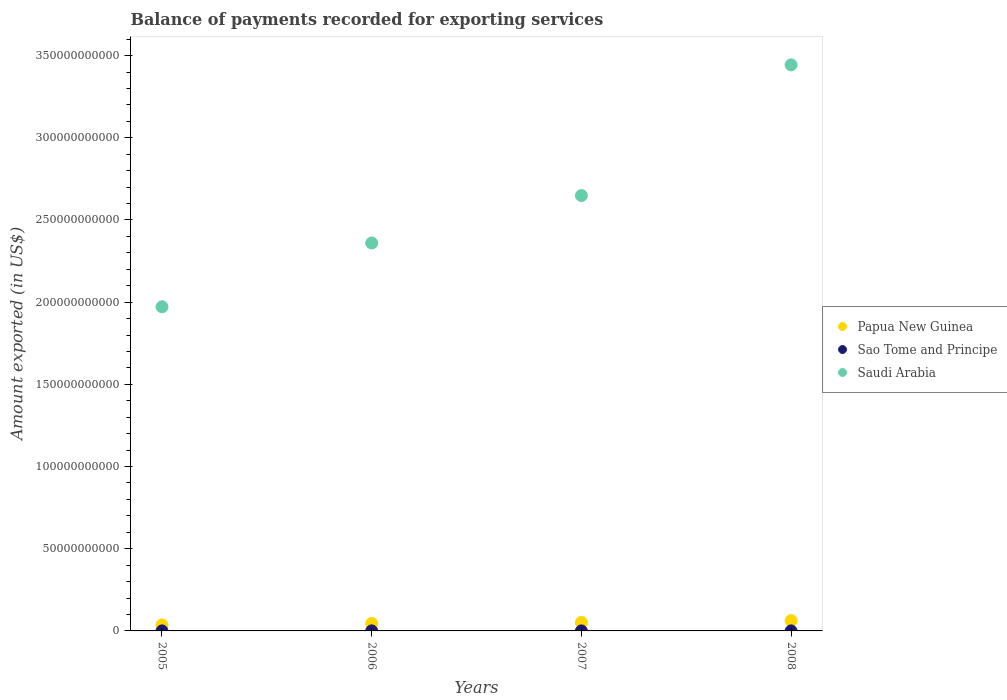How many different coloured dotlines are there?
Ensure brevity in your answer.  3. Is the number of dotlines equal to the number of legend labels?
Offer a terse response. Yes. What is the amount exported in Saudi Arabia in 2007?
Your response must be concise. 2.65e+11. Across all years, what is the maximum amount exported in Saudi Arabia?
Your answer should be compact. 3.44e+11. Across all years, what is the minimum amount exported in Sao Tome and Principe?
Give a very brief answer. 1.79e+07. In which year was the amount exported in Saudi Arabia minimum?
Your response must be concise. 2005. What is the total amount exported in Sao Tome and Principe in the graph?
Ensure brevity in your answer.  7.99e+07. What is the difference between the amount exported in Papua New Guinea in 2006 and that in 2007?
Your answer should be very brief. -6.08e+08. What is the difference between the amount exported in Saudi Arabia in 2006 and the amount exported in Sao Tome and Principe in 2008?
Provide a succinct answer. 2.36e+11. What is the average amount exported in Papua New Guinea per year?
Keep it short and to the point. 4.93e+09. In the year 2008, what is the difference between the amount exported in Saudi Arabia and amount exported in Sao Tome and Principe?
Offer a very short reply. 3.44e+11. In how many years, is the amount exported in Sao Tome and Principe greater than 30000000000 US$?
Your answer should be very brief. 0. What is the ratio of the amount exported in Papua New Guinea in 2005 to that in 2008?
Your answer should be compact. 0.58. What is the difference between the highest and the second highest amount exported in Papua New Guinea?
Your response must be concise. 1.05e+09. What is the difference between the highest and the lowest amount exported in Sao Tome and Principe?
Offer a very short reply. 4.35e+06. In how many years, is the amount exported in Sao Tome and Principe greater than the average amount exported in Sao Tome and Principe taken over all years?
Your answer should be compact. 2. Is the sum of the amount exported in Saudi Arabia in 2007 and 2008 greater than the maximum amount exported in Sao Tome and Principe across all years?
Offer a terse response. Yes. Is it the case that in every year, the sum of the amount exported in Saudi Arabia and amount exported in Sao Tome and Principe  is greater than the amount exported in Papua New Guinea?
Ensure brevity in your answer.  Yes. Does the amount exported in Saudi Arabia monotonically increase over the years?
Provide a succinct answer. Yes. Is the amount exported in Sao Tome and Principe strictly greater than the amount exported in Papua New Guinea over the years?
Your answer should be very brief. No. How many dotlines are there?
Provide a succinct answer. 3. How many years are there in the graph?
Keep it short and to the point. 4. Are the values on the major ticks of Y-axis written in scientific E-notation?
Your answer should be very brief. No. Does the graph contain any zero values?
Your answer should be compact. No. Does the graph contain grids?
Provide a short and direct response. No. How many legend labels are there?
Offer a very short reply. 3. How are the legend labels stacked?
Your answer should be very brief. Vertical. What is the title of the graph?
Give a very brief answer. Balance of payments recorded for exporting services. Does "Liberia" appear as one of the legend labels in the graph?
Offer a terse response. No. What is the label or title of the X-axis?
Provide a short and direct response. Years. What is the label or title of the Y-axis?
Keep it short and to the point. Amount exported (in US$). What is the Amount exported (in US$) in Papua New Guinea in 2005?
Keep it short and to the point. 3.65e+09. What is the Amount exported (in US$) in Sao Tome and Principe in 2005?
Ensure brevity in your answer.  1.79e+07. What is the Amount exported (in US$) of Saudi Arabia in 2005?
Make the answer very short. 1.97e+11. What is the Amount exported (in US$) of Papua New Guinea in 2006?
Give a very brief answer. 4.60e+09. What is the Amount exported (in US$) of Sao Tome and Principe in 2006?
Ensure brevity in your answer.  2.23e+07. What is the Amount exported (in US$) in Saudi Arabia in 2006?
Your answer should be very brief. 2.36e+11. What is the Amount exported (in US$) in Papua New Guinea in 2007?
Make the answer very short. 5.20e+09. What is the Amount exported (in US$) in Sao Tome and Principe in 2007?
Keep it short and to the point. 2.03e+07. What is the Amount exported (in US$) of Saudi Arabia in 2007?
Give a very brief answer. 2.65e+11. What is the Amount exported (in US$) of Papua New Guinea in 2008?
Offer a terse response. 6.26e+09. What is the Amount exported (in US$) in Sao Tome and Principe in 2008?
Your response must be concise. 1.94e+07. What is the Amount exported (in US$) in Saudi Arabia in 2008?
Your answer should be compact. 3.44e+11. Across all years, what is the maximum Amount exported (in US$) in Papua New Guinea?
Keep it short and to the point. 6.26e+09. Across all years, what is the maximum Amount exported (in US$) of Sao Tome and Principe?
Provide a succinct answer. 2.23e+07. Across all years, what is the maximum Amount exported (in US$) in Saudi Arabia?
Provide a succinct answer. 3.44e+11. Across all years, what is the minimum Amount exported (in US$) of Papua New Guinea?
Provide a short and direct response. 3.65e+09. Across all years, what is the minimum Amount exported (in US$) of Sao Tome and Principe?
Give a very brief answer. 1.79e+07. Across all years, what is the minimum Amount exported (in US$) in Saudi Arabia?
Make the answer very short. 1.97e+11. What is the total Amount exported (in US$) of Papua New Guinea in the graph?
Provide a succinct answer. 1.97e+1. What is the total Amount exported (in US$) of Sao Tome and Principe in the graph?
Keep it short and to the point. 7.99e+07. What is the total Amount exported (in US$) of Saudi Arabia in the graph?
Make the answer very short. 1.04e+12. What is the difference between the Amount exported (in US$) of Papua New Guinea in 2005 and that in 2006?
Your response must be concise. -9.48e+08. What is the difference between the Amount exported (in US$) of Sao Tome and Principe in 2005 and that in 2006?
Give a very brief answer. -4.35e+06. What is the difference between the Amount exported (in US$) of Saudi Arabia in 2005 and that in 2006?
Ensure brevity in your answer.  -3.88e+1. What is the difference between the Amount exported (in US$) of Papua New Guinea in 2005 and that in 2007?
Make the answer very short. -1.56e+09. What is the difference between the Amount exported (in US$) of Sao Tome and Principe in 2005 and that in 2007?
Ensure brevity in your answer.  -2.36e+06. What is the difference between the Amount exported (in US$) of Saudi Arabia in 2005 and that in 2007?
Offer a very short reply. -6.77e+1. What is the difference between the Amount exported (in US$) in Papua New Guinea in 2005 and that in 2008?
Your answer should be compact. -2.61e+09. What is the difference between the Amount exported (in US$) of Sao Tome and Principe in 2005 and that in 2008?
Give a very brief answer. -1.53e+06. What is the difference between the Amount exported (in US$) in Saudi Arabia in 2005 and that in 2008?
Ensure brevity in your answer.  -1.47e+11. What is the difference between the Amount exported (in US$) in Papua New Guinea in 2006 and that in 2007?
Provide a succinct answer. -6.08e+08. What is the difference between the Amount exported (in US$) of Sao Tome and Principe in 2006 and that in 2007?
Keep it short and to the point. 1.99e+06. What is the difference between the Amount exported (in US$) of Saudi Arabia in 2006 and that in 2007?
Ensure brevity in your answer.  -2.89e+1. What is the difference between the Amount exported (in US$) of Papua New Guinea in 2006 and that in 2008?
Give a very brief answer. -1.66e+09. What is the difference between the Amount exported (in US$) in Sao Tome and Principe in 2006 and that in 2008?
Offer a terse response. 2.82e+06. What is the difference between the Amount exported (in US$) in Saudi Arabia in 2006 and that in 2008?
Provide a short and direct response. -1.08e+11. What is the difference between the Amount exported (in US$) in Papua New Guinea in 2007 and that in 2008?
Your answer should be very brief. -1.05e+09. What is the difference between the Amount exported (in US$) in Sao Tome and Principe in 2007 and that in 2008?
Offer a terse response. 8.26e+05. What is the difference between the Amount exported (in US$) in Saudi Arabia in 2007 and that in 2008?
Your response must be concise. -7.95e+1. What is the difference between the Amount exported (in US$) in Papua New Guinea in 2005 and the Amount exported (in US$) in Sao Tome and Principe in 2006?
Offer a very short reply. 3.63e+09. What is the difference between the Amount exported (in US$) in Papua New Guinea in 2005 and the Amount exported (in US$) in Saudi Arabia in 2006?
Provide a succinct answer. -2.32e+11. What is the difference between the Amount exported (in US$) of Sao Tome and Principe in 2005 and the Amount exported (in US$) of Saudi Arabia in 2006?
Provide a succinct answer. -2.36e+11. What is the difference between the Amount exported (in US$) of Papua New Guinea in 2005 and the Amount exported (in US$) of Sao Tome and Principe in 2007?
Your answer should be very brief. 3.63e+09. What is the difference between the Amount exported (in US$) in Papua New Guinea in 2005 and the Amount exported (in US$) in Saudi Arabia in 2007?
Keep it short and to the point. -2.61e+11. What is the difference between the Amount exported (in US$) of Sao Tome and Principe in 2005 and the Amount exported (in US$) of Saudi Arabia in 2007?
Provide a short and direct response. -2.65e+11. What is the difference between the Amount exported (in US$) in Papua New Guinea in 2005 and the Amount exported (in US$) in Sao Tome and Principe in 2008?
Provide a short and direct response. 3.63e+09. What is the difference between the Amount exported (in US$) of Papua New Guinea in 2005 and the Amount exported (in US$) of Saudi Arabia in 2008?
Offer a terse response. -3.41e+11. What is the difference between the Amount exported (in US$) in Sao Tome and Principe in 2005 and the Amount exported (in US$) in Saudi Arabia in 2008?
Your response must be concise. -3.44e+11. What is the difference between the Amount exported (in US$) in Papua New Guinea in 2006 and the Amount exported (in US$) in Sao Tome and Principe in 2007?
Ensure brevity in your answer.  4.58e+09. What is the difference between the Amount exported (in US$) of Papua New Guinea in 2006 and the Amount exported (in US$) of Saudi Arabia in 2007?
Give a very brief answer. -2.60e+11. What is the difference between the Amount exported (in US$) of Sao Tome and Principe in 2006 and the Amount exported (in US$) of Saudi Arabia in 2007?
Your answer should be compact. -2.65e+11. What is the difference between the Amount exported (in US$) in Papua New Guinea in 2006 and the Amount exported (in US$) in Sao Tome and Principe in 2008?
Give a very brief answer. 4.58e+09. What is the difference between the Amount exported (in US$) in Papua New Guinea in 2006 and the Amount exported (in US$) in Saudi Arabia in 2008?
Provide a short and direct response. -3.40e+11. What is the difference between the Amount exported (in US$) in Sao Tome and Principe in 2006 and the Amount exported (in US$) in Saudi Arabia in 2008?
Ensure brevity in your answer.  -3.44e+11. What is the difference between the Amount exported (in US$) of Papua New Guinea in 2007 and the Amount exported (in US$) of Sao Tome and Principe in 2008?
Provide a succinct answer. 5.19e+09. What is the difference between the Amount exported (in US$) in Papua New Guinea in 2007 and the Amount exported (in US$) in Saudi Arabia in 2008?
Your answer should be very brief. -3.39e+11. What is the difference between the Amount exported (in US$) in Sao Tome and Principe in 2007 and the Amount exported (in US$) in Saudi Arabia in 2008?
Offer a very short reply. -3.44e+11. What is the average Amount exported (in US$) of Papua New Guinea per year?
Keep it short and to the point. 4.93e+09. What is the average Amount exported (in US$) in Sao Tome and Principe per year?
Provide a succinct answer. 2.00e+07. What is the average Amount exported (in US$) in Saudi Arabia per year?
Your answer should be very brief. 2.61e+11. In the year 2005, what is the difference between the Amount exported (in US$) in Papua New Guinea and Amount exported (in US$) in Sao Tome and Principe?
Offer a very short reply. 3.63e+09. In the year 2005, what is the difference between the Amount exported (in US$) of Papua New Guinea and Amount exported (in US$) of Saudi Arabia?
Keep it short and to the point. -1.94e+11. In the year 2005, what is the difference between the Amount exported (in US$) of Sao Tome and Principe and Amount exported (in US$) of Saudi Arabia?
Ensure brevity in your answer.  -1.97e+11. In the year 2006, what is the difference between the Amount exported (in US$) in Papua New Guinea and Amount exported (in US$) in Sao Tome and Principe?
Your answer should be very brief. 4.57e+09. In the year 2006, what is the difference between the Amount exported (in US$) in Papua New Guinea and Amount exported (in US$) in Saudi Arabia?
Provide a succinct answer. -2.31e+11. In the year 2006, what is the difference between the Amount exported (in US$) in Sao Tome and Principe and Amount exported (in US$) in Saudi Arabia?
Your answer should be compact. -2.36e+11. In the year 2007, what is the difference between the Amount exported (in US$) in Papua New Guinea and Amount exported (in US$) in Sao Tome and Principe?
Keep it short and to the point. 5.18e+09. In the year 2007, what is the difference between the Amount exported (in US$) of Papua New Guinea and Amount exported (in US$) of Saudi Arabia?
Make the answer very short. -2.60e+11. In the year 2007, what is the difference between the Amount exported (in US$) in Sao Tome and Principe and Amount exported (in US$) in Saudi Arabia?
Give a very brief answer. -2.65e+11. In the year 2008, what is the difference between the Amount exported (in US$) of Papua New Guinea and Amount exported (in US$) of Sao Tome and Principe?
Provide a succinct answer. 6.24e+09. In the year 2008, what is the difference between the Amount exported (in US$) in Papua New Guinea and Amount exported (in US$) in Saudi Arabia?
Ensure brevity in your answer.  -3.38e+11. In the year 2008, what is the difference between the Amount exported (in US$) of Sao Tome and Principe and Amount exported (in US$) of Saudi Arabia?
Give a very brief answer. -3.44e+11. What is the ratio of the Amount exported (in US$) in Papua New Guinea in 2005 to that in 2006?
Ensure brevity in your answer.  0.79. What is the ratio of the Amount exported (in US$) in Sao Tome and Principe in 2005 to that in 2006?
Provide a succinct answer. 0.8. What is the ratio of the Amount exported (in US$) of Saudi Arabia in 2005 to that in 2006?
Provide a short and direct response. 0.84. What is the ratio of the Amount exported (in US$) in Papua New Guinea in 2005 to that in 2007?
Give a very brief answer. 0.7. What is the ratio of the Amount exported (in US$) of Sao Tome and Principe in 2005 to that in 2007?
Your response must be concise. 0.88. What is the ratio of the Amount exported (in US$) of Saudi Arabia in 2005 to that in 2007?
Ensure brevity in your answer.  0.74. What is the ratio of the Amount exported (in US$) in Papua New Guinea in 2005 to that in 2008?
Make the answer very short. 0.58. What is the ratio of the Amount exported (in US$) in Sao Tome and Principe in 2005 to that in 2008?
Your answer should be very brief. 0.92. What is the ratio of the Amount exported (in US$) of Saudi Arabia in 2005 to that in 2008?
Your response must be concise. 0.57. What is the ratio of the Amount exported (in US$) in Papua New Guinea in 2006 to that in 2007?
Your answer should be compact. 0.88. What is the ratio of the Amount exported (in US$) of Sao Tome and Principe in 2006 to that in 2007?
Offer a very short reply. 1.1. What is the ratio of the Amount exported (in US$) in Saudi Arabia in 2006 to that in 2007?
Offer a terse response. 0.89. What is the ratio of the Amount exported (in US$) of Papua New Guinea in 2006 to that in 2008?
Keep it short and to the point. 0.73. What is the ratio of the Amount exported (in US$) of Sao Tome and Principe in 2006 to that in 2008?
Offer a very short reply. 1.15. What is the ratio of the Amount exported (in US$) of Saudi Arabia in 2006 to that in 2008?
Your response must be concise. 0.69. What is the ratio of the Amount exported (in US$) in Papua New Guinea in 2007 to that in 2008?
Your answer should be very brief. 0.83. What is the ratio of the Amount exported (in US$) of Sao Tome and Principe in 2007 to that in 2008?
Offer a terse response. 1.04. What is the ratio of the Amount exported (in US$) in Saudi Arabia in 2007 to that in 2008?
Your answer should be very brief. 0.77. What is the difference between the highest and the second highest Amount exported (in US$) of Papua New Guinea?
Keep it short and to the point. 1.05e+09. What is the difference between the highest and the second highest Amount exported (in US$) of Sao Tome and Principe?
Offer a very short reply. 1.99e+06. What is the difference between the highest and the second highest Amount exported (in US$) in Saudi Arabia?
Offer a very short reply. 7.95e+1. What is the difference between the highest and the lowest Amount exported (in US$) in Papua New Guinea?
Offer a terse response. 2.61e+09. What is the difference between the highest and the lowest Amount exported (in US$) in Sao Tome and Principe?
Offer a terse response. 4.35e+06. What is the difference between the highest and the lowest Amount exported (in US$) of Saudi Arabia?
Your response must be concise. 1.47e+11. 